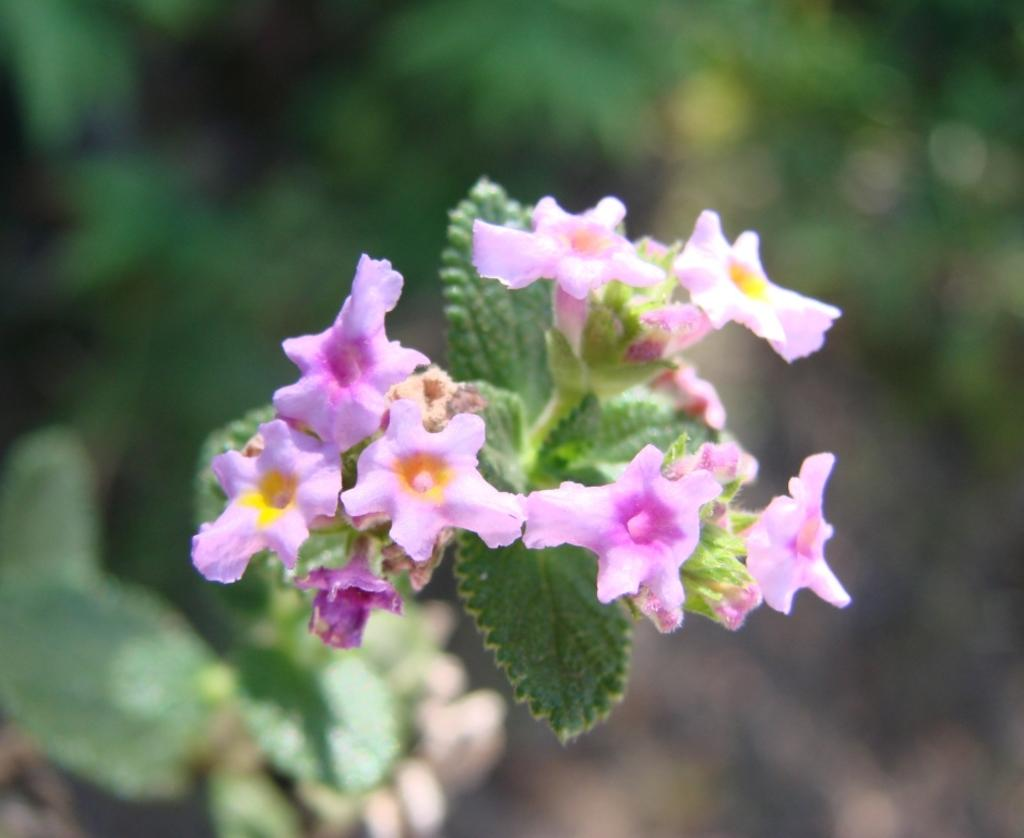What type of plant life can be seen in the image? There are leaves and flowers in the image. What color is the background of the image? The background of the image is blue. What type of mark can be seen on the leaves in the image? There is no mark visible on the leaves in the image. Is there a cub present in the image? There is no cub present in the image; it features leaves and flowers against a blue background. 